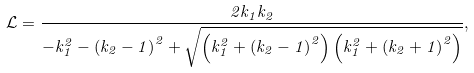Convert formula to latex. <formula><loc_0><loc_0><loc_500><loc_500>\mathcal { L } = { \frac { 2 { k _ { 1 } } { k _ { 2 } } } { - k _ { 1 } ^ { 2 } - { { \left ( { { k _ { 2 } } - 1 } \right ) } ^ { 2 } } + \sqrt { \left ( { k _ { 1 } ^ { 2 } + { { \left ( { { k _ { 2 } } - 1 } \right ) } ^ { 2 } } } \right ) \left ( { k _ { 1 } ^ { 2 } + { { \left ( { { k _ { 2 } } + 1 } \right ) } ^ { 2 } } } \right ) } } } ,</formula> 